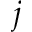<formula> <loc_0><loc_0><loc_500><loc_500>j</formula> 